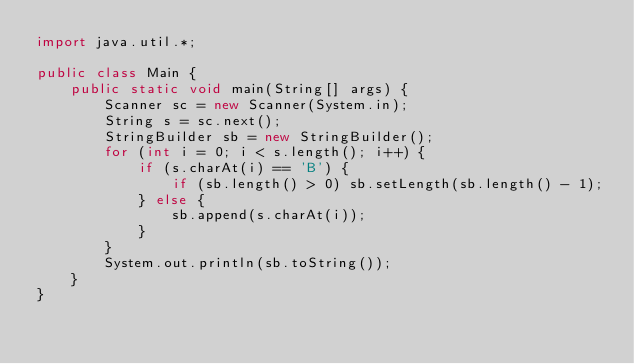Convert code to text. <code><loc_0><loc_0><loc_500><loc_500><_Java_>import java.util.*;

public class Main {
    public static void main(String[] args) {
        Scanner sc = new Scanner(System.in);
        String s = sc.next();
        StringBuilder sb = new StringBuilder();
        for (int i = 0; i < s.length(); i++) {
            if (s.charAt(i) == 'B') {
                if (sb.length() > 0) sb.setLength(sb.length() - 1);
            } else {
                sb.append(s.charAt(i));
            }
        }
        System.out.println(sb.toString());
    }
}
</code> 